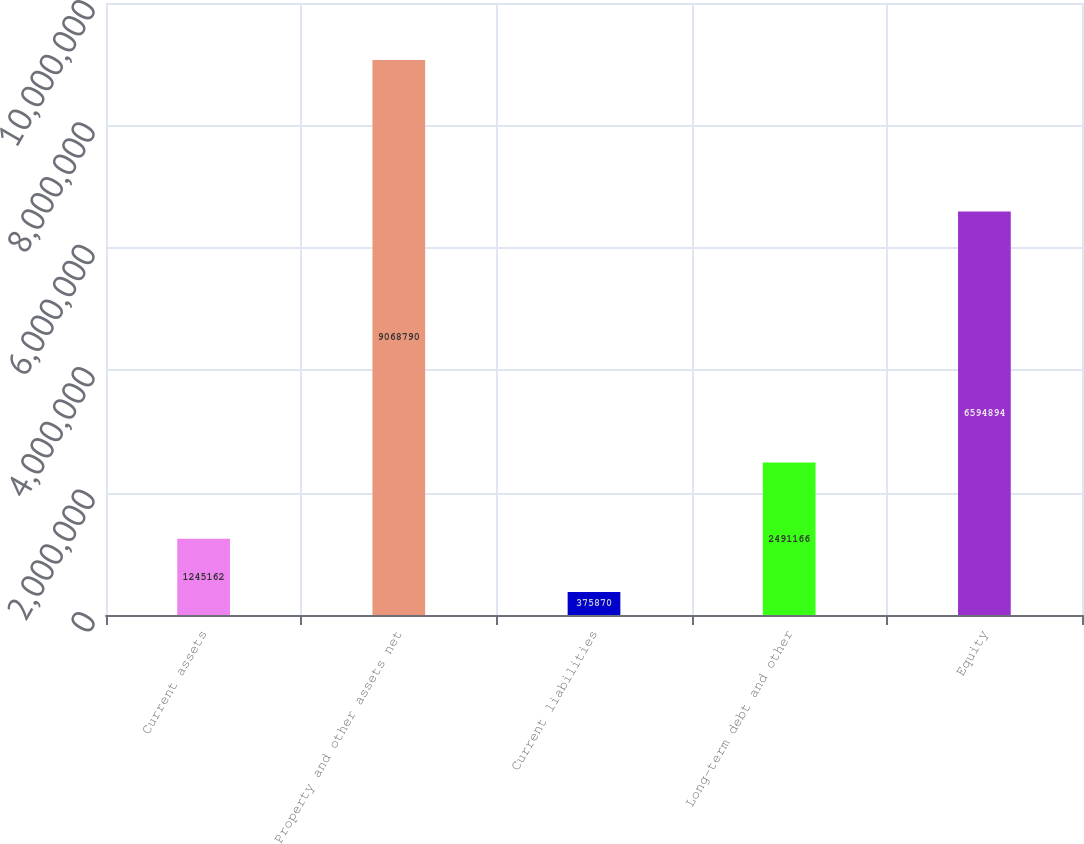<chart> <loc_0><loc_0><loc_500><loc_500><bar_chart><fcel>Current assets<fcel>Property and other assets net<fcel>Current liabilities<fcel>Long-term debt and other<fcel>Equity<nl><fcel>1.24516e+06<fcel>9.06879e+06<fcel>375870<fcel>2.49117e+06<fcel>6.59489e+06<nl></chart> 